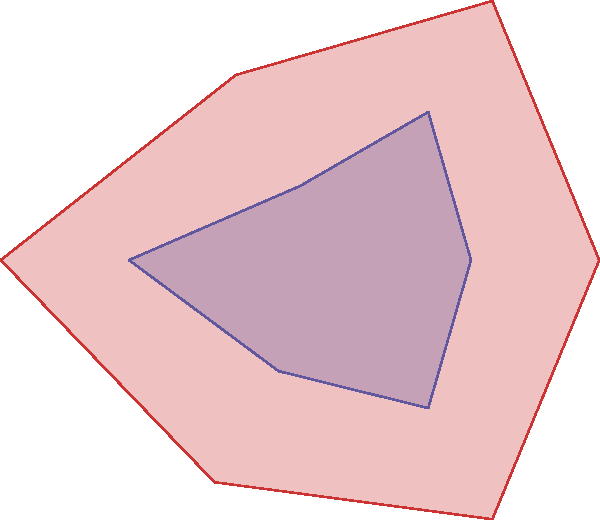In this polar rose diagram representing political polarization trends, what striking change do you observe between the years 2000 and 2020 that could fuel a provocative discussion on your talk show about the widening political divide in our nation? To analyze this polar rose diagram of political polarization trends:

1. Identify the two shapes:
   - Blue shape represents data from 2000
   - Red shape represents data from 2020

2. Compare the sizes:
   - The 2020 (red) shape is significantly larger than the 2000 (blue) shape

3. Interpret the diagram:
   - Each petal of the rose represents a different aspect of political polarization
   - The length of each petal indicates the intensity of polarization in that aspect

4. Observe the change:
   - All petals have grown longer from 2000 to 2020
   - This indicates an increase in polarization across all measured aspects

5. Quantify the change:
   - The 2020 shape is approximately 1.5 to 2 times larger than the 2000 shape
   - This suggests a 50% to 100% increase in overall political polarization

6. Consider the implications:
   - The substantial growth in all directions implies a drastic intensification of political divisions
   - This change could be described as a "dramatic widening" of the political divide

The most striking change is the overall expansion of the shape, indicating a significant increase in political polarization across all measured aspects between 2000 and 2020.
Answer: Dramatic widening of the political divide across all aspects 